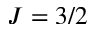<formula> <loc_0><loc_0><loc_500><loc_500>J = 3 / 2</formula> 